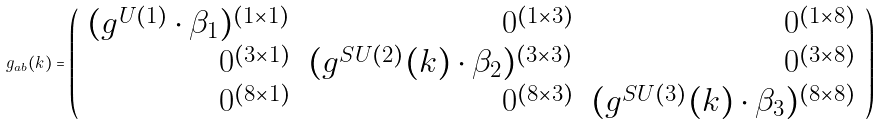Convert formula to latex. <formula><loc_0><loc_0><loc_500><loc_500>g _ { a b } ( k ) = \left ( \begin{array} { r r r } ( g ^ { U ( 1 ) } \cdot \beta _ { 1 } ) ^ { ( 1 \times 1 ) } & 0 ^ { ( 1 \times 3 ) } & 0 ^ { ( 1 \times 8 ) } \\ 0 ^ { ( 3 \times 1 ) } & ( g ^ { S U ( 2 ) } ( k ) \cdot \beta _ { 2 } ) ^ { ( 3 \times 3 ) } & 0 ^ { ( 3 \times 8 ) } \\ 0 ^ { ( 8 \times 1 ) } & 0 ^ { ( 8 \times 3 ) } & ( g ^ { S U ( 3 ) } ( k ) \cdot \beta _ { 3 } ) ^ { ( 8 \times 8 ) } \end{array} \right )</formula> 